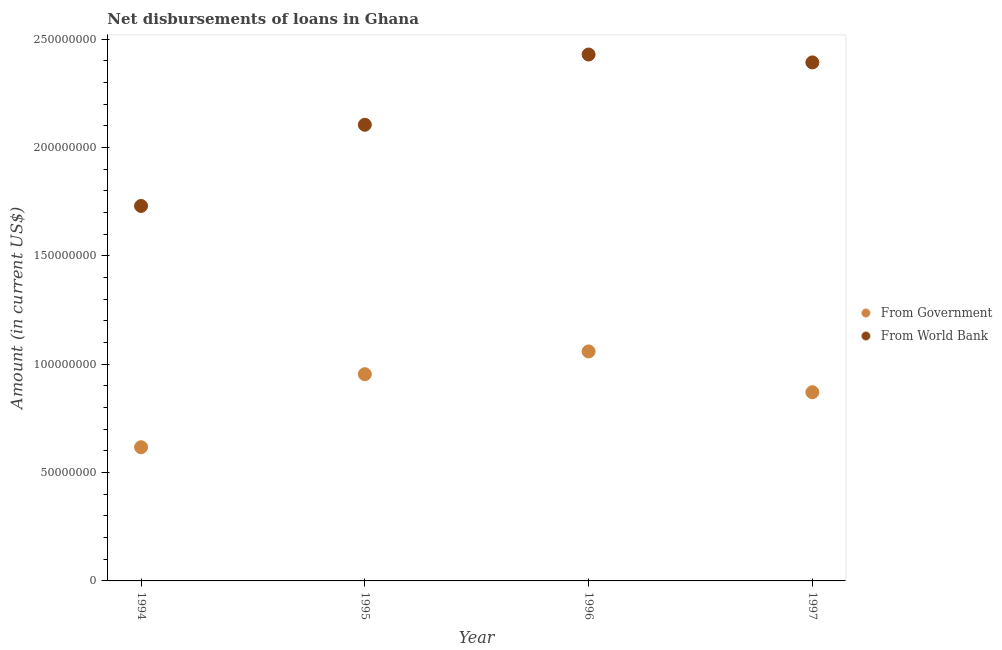How many different coloured dotlines are there?
Offer a terse response. 2. What is the net disbursements of loan from world bank in 1997?
Offer a very short reply. 2.39e+08. Across all years, what is the maximum net disbursements of loan from government?
Ensure brevity in your answer.  1.06e+08. Across all years, what is the minimum net disbursements of loan from world bank?
Your answer should be compact. 1.73e+08. In which year was the net disbursements of loan from world bank minimum?
Keep it short and to the point. 1994. What is the total net disbursements of loan from world bank in the graph?
Your answer should be very brief. 8.66e+08. What is the difference between the net disbursements of loan from government in 1994 and that in 1997?
Your answer should be very brief. -2.54e+07. What is the difference between the net disbursements of loan from government in 1997 and the net disbursements of loan from world bank in 1995?
Offer a terse response. -1.23e+08. What is the average net disbursements of loan from world bank per year?
Your answer should be compact. 2.16e+08. In the year 1995, what is the difference between the net disbursements of loan from world bank and net disbursements of loan from government?
Provide a short and direct response. 1.15e+08. In how many years, is the net disbursements of loan from world bank greater than 60000000 US$?
Offer a very short reply. 4. What is the ratio of the net disbursements of loan from world bank in 1994 to that in 1995?
Provide a short and direct response. 0.82. Is the net disbursements of loan from world bank in 1995 less than that in 1997?
Your response must be concise. Yes. Is the difference between the net disbursements of loan from government in 1994 and 1997 greater than the difference between the net disbursements of loan from world bank in 1994 and 1997?
Ensure brevity in your answer.  Yes. What is the difference between the highest and the second highest net disbursements of loan from government?
Keep it short and to the point. 1.05e+07. What is the difference between the highest and the lowest net disbursements of loan from world bank?
Your answer should be very brief. 6.99e+07. In how many years, is the net disbursements of loan from government greater than the average net disbursements of loan from government taken over all years?
Keep it short and to the point. 2. Is the sum of the net disbursements of loan from government in 1994 and 1997 greater than the maximum net disbursements of loan from world bank across all years?
Offer a terse response. No. What is the difference between two consecutive major ticks on the Y-axis?
Make the answer very short. 5.00e+07. Does the graph contain any zero values?
Ensure brevity in your answer.  No. Where does the legend appear in the graph?
Ensure brevity in your answer.  Center right. What is the title of the graph?
Your answer should be very brief. Net disbursements of loans in Ghana. Does "Education" appear as one of the legend labels in the graph?
Offer a terse response. No. What is the label or title of the X-axis?
Your answer should be very brief. Year. What is the Amount (in current US$) in From Government in 1994?
Keep it short and to the point. 6.17e+07. What is the Amount (in current US$) of From World Bank in 1994?
Provide a short and direct response. 1.73e+08. What is the Amount (in current US$) in From Government in 1995?
Give a very brief answer. 9.54e+07. What is the Amount (in current US$) of From World Bank in 1995?
Make the answer very short. 2.11e+08. What is the Amount (in current US$) in From Government in 1996?
Offer a very short reply. 1.06e+08. What is the Amount (in current US$) of From World Bank in 1996?
Your answer should be very brief. 2.43e+08. What is the Amount (in current US$) in From Government in 1997?
Make the answer very short. 8.71e+07. What is the Amount (in current US$) of From World Bank in 1997?
Offer a terse response. 2.39e+08. Across all years, what is the maximum Amount (in current US$) in From Government?
Offer a very short reply. 1.06e+08. Across all years, what is the maximum Amount (in current US$) of From World Bank?
Your response must be concise. 2.43e+08. Across all years, what is the minimum Amount (in current US$) in From Government?
Provide a short and direct response. 6.17e+07. Across all years, what is the minimum Amount (in current US$) of From World Bank?
Keep it short and to the point. 1.73e+08. What is the total Amount (in current US$) of From Government in the graph?
Your answer should be compact. 3.50e+08. What is the total Amount (in current US$) in From World Bank in the graph?
Provide a succinct answer. 8.66e+08. What is the difference between the Amount (in current US$) of From Government in 1994 and that in 1995?
Offer a terse response. -3.37e+07. What is the difference between the Amount (in current US$) in From World Bank in 1994 and that in 1995?
Provide a short and direct response. -3.75e+07. What is the difference between the Amount (in current US$) in From Government in 1994 and that in 1996?
Ensure brevity in your answer.  -4.42e+07. What is the difference between the Amount (in current US$) in From World Bank in 1994 and that in 1996?
Provide a short and direct response. -6.99e+07. What is the difference between the Amount (in current US$) of From Government in 1994 and that in 1997?
Your response must be concise. -2.54e+07. What is the difference between the Amount (in current US$) of From World Bank in 1994 and that in 1997?
Make the answer very short. -6.63e+07. What is the difference between the Amount (in current US$) of From Government in 1995 and that in 1996?
Provide a succinct answer. -1.05e+07. What is the difference between the Amount (in current US$) of From World Bank in 1995 and that in 1996?
Your answer should be compact. -3.24e+07. What is the difference between the Amount (in current US$) of From Government in 1995 and that in 1997?
Keep it short and to the point. 8.32e+06. What is the difference between the Amount (in current US$) of From World Bank in 1995 and that in 1997?
Your response must be concise. -2.88e+07. What is the difference between the Amount (in current US$) of From Government in 1996 and that in 1997?
Give a very brief answer. 1.88e+07. What is the difference between the Amount (in current US$) in From World Bank in 1996 and that in 1997?
Your answer should be very brief. 3.64e+06. What is the difference between the Amount (in current US$) in From Government in 1994 and the Amount (in current US$) in From World Bank in 1995?
Offer a very short reply. -1.49e+08. What is the difference between the Amount (in current US$) of From Government in 1994 and the Amount (in current US$) of From World Bank in 1996?
Provide a succinct answer. -1.81e+08. What is the difference between the Amount (in current US$) of From Government in 1994 and the Amount (in current US$) of From World Bank in 1997?
Your response must be concise. -1.78e+08. What is the difference between the Amount (in current US$) of From Government in 1995 and the Amount (in current US$) of From World Bank in 1996?
Offer a terse response. -1.48e+08. What is the difference between the Amount (in current US$) of From Government in 1995 and the Amount (in current US$) of From World Bank in 1997?
Keep it short and to the point. -1.44e+08. What is the difference between the Amount (in current US$) in From Government in 1996 and the Amount (in current US$) in From World Bank in 1997?
Provide a succinct answer. -1.33e+08. What is the average Amount (in current US$) of From Government per year?
Keep it short and to the point. 8.75e+07. What is the average Amount (in current US$) in From World Bank per year?
Offer a very short reply. 2.16e+08. In the year 1994, what is the difference between the Amount (in current US$) in From Government and Amount (in current US$) in From World Bank?
Give a very brief answer. -1.11e+08. In the year 1995, what is the difference between the Amount (in current US$) of From Government and Amount (in current US$) of From World Bank?
Your response must be concise. -1.15e+08. In the year 1996, what is the difference between the Amount (in current US$) in From Government and Amount (in current US$) in From World Bank?
Offer a very short reply. -1.37e+08. In the year 1997, what is the difference between the Amount (in current US$) of From Government and Amount (in current US$) of From World Bank?
Your answer should be compact. -1.52e+08. What is the ratio of the Amount (in current US$) in From Government in 1994 to that in 1995?
Give a very brief answer. 0.65. What is the ratio of the Amount (in current US$) of From World Bank in 1994 to that in 1995?
Make the answer very short. 0.82. What is the ratio of the Amount (in current US$) in From Government in 1994 to that in 1996?
Keep it short and to the point. 0.58. What is the ratio of the Amount (in current US$) of From World Bank in 1994 to that in 1996?
Ensure brevity in your answer.  0.71. What is the ratio of the Amount (in current US$) of From Government in 1994 to that in 1997?
Your response must be concise. 0.71. What is the ratio of the Amount (in current US$) in From World Bank in 1994 to that in 1997?
Ensure brevity in your answer.  0.72. What is the ratio of the Amount (in current US$) in From Government in 1995 to that in 1996?
Your answer should be compact. 0.9. What is the ratio of the Amount (in current US$) in From World Bank in 1995 to that in 1996?
Provide a short and direct response. 0.87. What is the ratio of the Amount (in current US$) of From Government in 1995 to that in 1997?
Offer a terse response. 1.1. What is the ratio of the Amount (in current US$) in From World Bank in 1995 to that in 1997?
Keep it short and to the point. 0.88. What is the ratio of the Amount (in current US$) of From Government in 1996 to that in 1997?
Your answer should be compact. 1.22. What is the ratio of the Amount (in current US$) of From World Bank in 1996 to that in 1997?
Ensure brevity in your answer.  1.02. What is the difference between the highest and the second highest Amount (in current US$) of From Government?
Your answer should be very brief. 1.05e+07. What is the difference between the highest and the second highest Amount (in current US$) of From World Bank?
Make the answer very short. 3.64e+06. What is the difference between the highest and the lowest Amount (in current US$) in From Government?
Offer a very short reply. 4.42e+07. What is the difference between the highest and the lowest Amount (in current US$) in From World Bank?
Provide a succinct answer. 6.99e+07. 